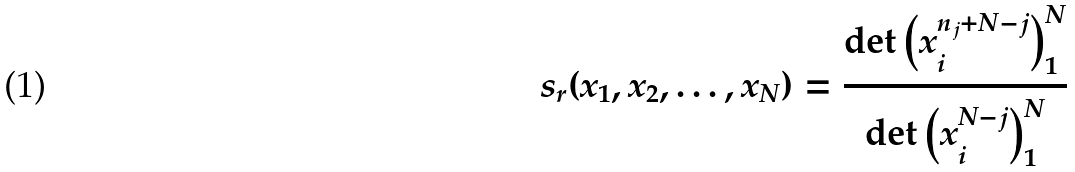<formula> <loc_0><loc_0><loc_500><loc_500>s _ { r } ( x _ { 1 } , x _ { 2 } , \dots , x _ { N } ) = \frac { \det { \left ( x _ { i } ^ { n _ { j } + N - j } \right ) _ { 1 } ^ { N } } } { \det { \left ( x _ { i } ^ { N - j } \right ) _ { 1 } ^ { N } } }</formula> 